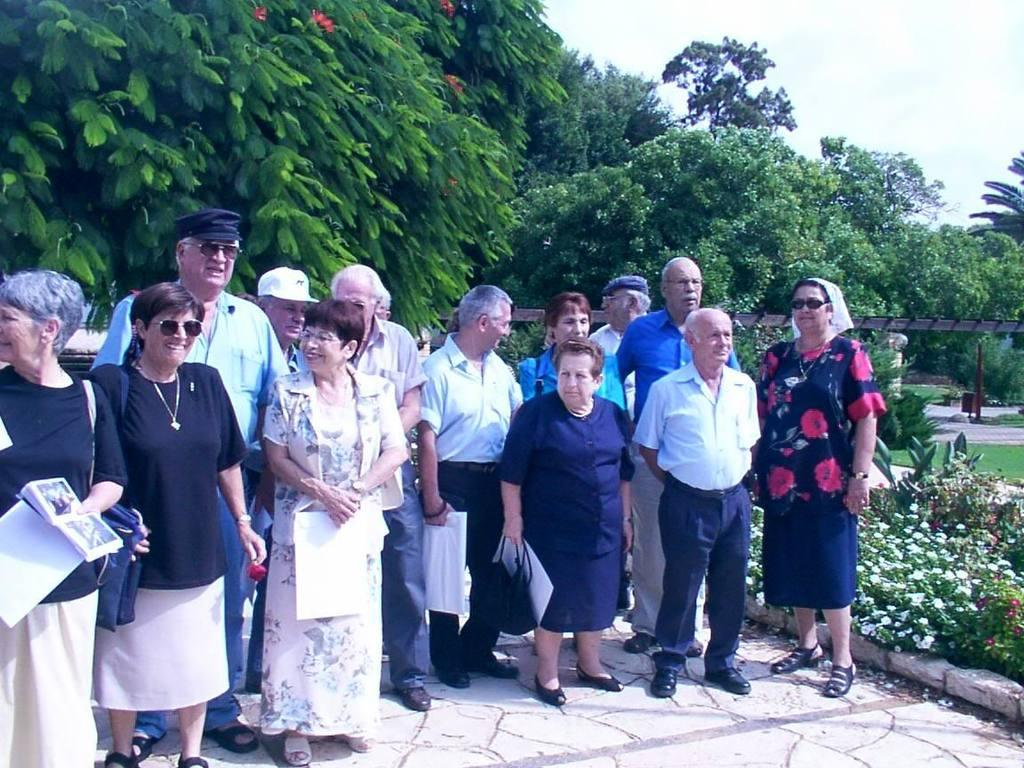What can be seen in the background of the image? The sky is visible in the background of the image. What type of vegetation is present in the image? There are trees, plants, grass, and flowers in the image. What else can be found in the image besides vegetation? There are objects and people in the image. What are some people doing in the image? Some people are standing and holding objects in their hands. How far away is the son in the image? There is no son present in the image. What type of rock can be seen in the image? There is no rock present in the image. 